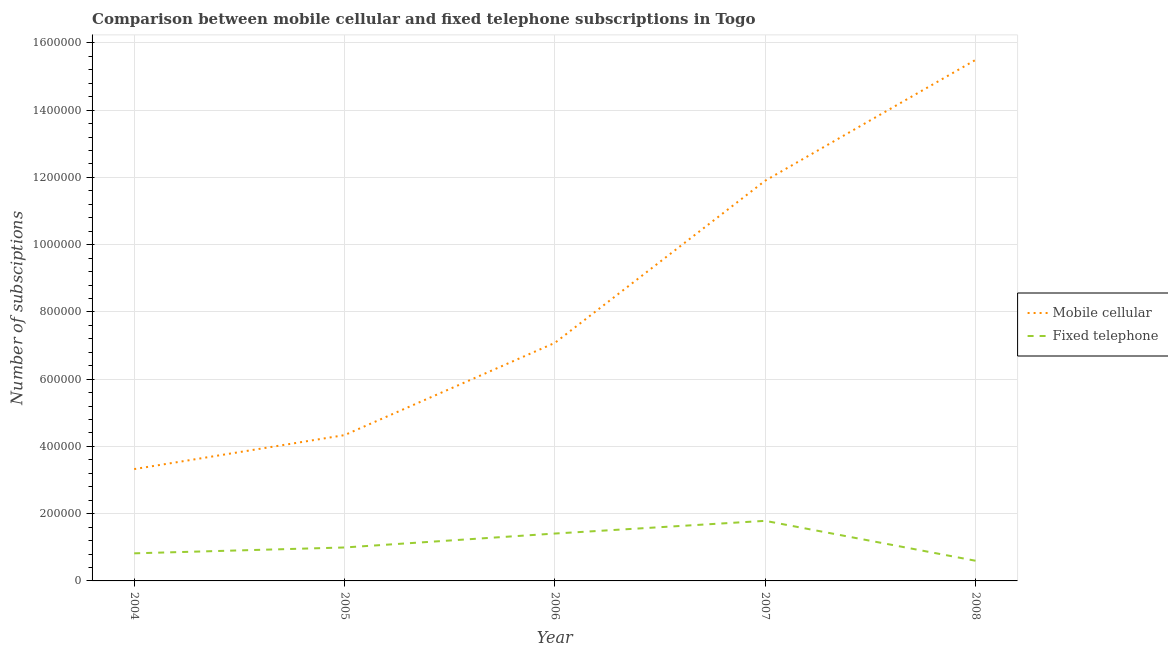Does the line corresponding to number of mobile cellular subscriptions intersect with the line corresponding to number of fixed telephone subscriptions?
Make the answer very short. No. What is the number of mobile cellular subscriptions in 2004?
Your answer should be very brief. 3.33e+05. Across all years, what is the maximum number of fixed telephone subscriptions?
Give a very brief answer. 1.79e+05. Across all years, what is the minimum number of fixed telephone subscriptions?
Provide a short and direct response. 6.00e+04. In which year was the number of mobile cellular subscriptions minimum?
Ensure brevity in your answer.  2004. What is the total number of mobile cellular subscriptions in the graph?
Make the answer very short. 4.21e+06. What is the difference between the number of fixed telephone subscriptions in 2006 and that in 2007?
Your response must be concise. -3.78e+04. What is the difference between the number of fixed telephone subscriptions in 2006 and the number of mobile cellular subscriptions in 2005?
Give a very brief answer. -2.93e+05. What is the average number of fixed telephone subscriptions per year?
Your answer should be compact. 1.12e+05. In the year 2007, what is the difference between the number of mobile cellular subscriptions and number of fixed telephone subscriptions?
Your answer should be very brief. 1.01e+06. What is the ratio of the number of mobile cellular subscriptions in 2004 to that in 2005?
Make the answer very short. 0.77. Is the number of mobile cellular subscriptions in 2006 less than that in 2007?
Give a very brief answer. Yes. What is the difference between the highest and the second highest number of mobile cellular subscriptions?
Give a very brief answer. 3.59e+05. What is the difference between the highest and the lowest number of fixed telephone subscriptions?
Your answer should be very brief. 1.19e+05. In how many years, is the number of mobile cellular subscriptions greater than the average number of mobile cellular subscriptions taken over all years?
Provide a succinct answer. 2. How many years are there in the graph?
Your response must be concise. 5. Does the graph contain any zero values?
Give a very brief answer. No. Where does the legend appear in the graph?
Provide a short and direct response. Center right. How many legend labels are there?
Offer a very short reply. 2. How are the legend labels stacked?
Ensure brevity in your answer.  Vertical. What is the title of the graph?
Provide a succinct answer. Comparison between mobile cellular and fixed telephone subscriptions in Togo. What is the label or title of the X-axis?
Offer a terse response. Year. What is the label or title of the Y-axis?
Your response must be concise. Number of subsciptions. What is the Number of subsciptions in Mobile cellular in 2004?
Offer a very short reply. 3.33e+05. What is the Number of subsciptions in Fixed telephone in 2004?
Give a very brief answer. 8.21e+04. What is the Number of subsciptions in Mobile cellular in 2005?
Provide a succinct answer. 4.34e+05. What is the Number of subsciptions of Fixed telephone in 2005?
Make the answer very short. 9.95e+04. What is the Number of subsciptions of Mobile cellular in 2006?
Provide a short and direct response. 7.08e+05. What is the Number of subsciptions of Fixed telephone in 2006?
Offer a very short reply. 1.41e+05. What is the Number of subsciptions in Mobile cellular in 2007?
Keep it short and to the point. 1.19e+06. What is the Number of subsciptions of Fixed telephone in 2007?
Keep it short and to the point. 1.79e+05. What is the Number of subsciptions in Mobile cellular in 2008?
Keep it short and to the point. 1.55e+06. What is the Number of subsciptions in Fixed telephone in 2008?
Ensure brevity in your answer.  6.00e+04. Across all years, what is the maximum Number of subsciptions in Mobile cellular?
Your response must be concise. 1.55e+06. Across all years, what is the maximum Number of subsciptions of Fixed telephone?
Your answer should be compact. 1.79e+05. Across all years, what is the minimum Number of subsciptions of Mobile cellular?
Your answer should be compact. 3.33e+05. Across all years, what is the minimum Number of subsciptions of Fixed telephone?
Keep it short and to the point. 6.00e+04. What is the total Number of subsciptions in Mobile cellular in the graph?
Ensure brevity in your answer.  4.21e+06. What is the total Number of subsciptions of Fixed telephone in the graph?
Give a very brief answer. 5.61e+05. What is the difference between the Number of subsciptions of Mobile cellular in 2004 and that in 2005?
Your answer should be compact. -1.01e+05. What is the difference between the Number of subsciptions of Fixed telephone in 2004 and that in 2005?
Provide a succinct answer. -1.74e+04. What is the difference between the Number of subsciptions in Mobile cellular in 2004 and that in 2006?
Give a very brief answer. -3.75e+05. What is the difference between the Number of subsciptions of Fixed telephone in 2004 and that in 2006?
Give a very brief answer. -5.89e+04. What is the difference between the Number of subsciptions in Mobile cellular in 2004 and that in 2007?
Provide a short and direct response. -8.58e+05. What is the difference between the Number of subsciptions in Fixed telephone in 2004 and that in 2007?
Your response must be concise. -9.67e+04. What is the difference between the Number of subsciptions in Mobile cellular in 2004 and that in 2008?
Make the answer very short. -1.22e+06. What is the difference between the Number of subsciptions in Fixed telephone in 2004 and that in 2008?
Your answer should be very brief. 2.20e+04. What is the difference between the Number of subsciptions in Mobile cellular in 2005 and that in 2006?
Your answer should be very brief. -2.74e+05. What is the difference between the Number of subsciptions of Fixed telephone in 2005 and that in 2006?
Give a very brief answer. -4.14e+04. What is the difference between the Number of subsciptions in Mobile cellular in 2005 and that in 2007?
Provide a short and direct response. -7.57e+05. What is the difference between the Number of subsciptions of Fixed telephone in 2005 and that in 2007?
Your answer should be compact. -7.92e+04. What is the difference between the Number of subsciptions of Mobile cellular in 2005 and that in 2008?
Ensure brevity in your answer.  -1.12e+06. What is the difference between the Number of subsciptions in Fixed telephone in 2005 and that in 2008?
Provide a succinct answer. 3.95e+04. What is the difference between the Number of subsciptions of Mobile cellular in 2006 and that in 2007?
Ensure brevity in your answer.  -4.82e+05. What is the difference between the Number of subsciptions in Fixed telephone in 2006 and that in 2007?
Provide a succinct answer. -3.78e+04. What is the difference between the Number of subsciptions in Mobile cellular in 2006 and that in 2008?
Ensure brevity in your answer.  -8.42e+05. What is the difference between the Number of subsciptions in Fixed telephone in 2006 and that in 2008?
Your answer should be very brief. 8.09e+04. What is the difference between the Number of subsciptions in Mobile cellular in 2007 and that in 2008?
Provide a succinct answer. -3.59e+05. What is the difference between the Number of subsciptions in Fixed telephone in 2007 and that in 2008?
Provide a succinct answer. 1.19e+05. What is the difference between the Number of subsciptions of Mobile cellular in 2004 and the Number of subsciptions of Fixed telephone in 2005?
Ensure brevity in your answer.  2.33e+05. What is the difference between the Number of subsciptions of Mobile cellular in 2004 and the Number of subsciptions of Fixed telephone in 2006?
Ensure brevity in your answer.  1.92e+05. What is the difference between the Number of subsciptions of Mobile cellular in 2004 and the Number of subsciptions of Fixed telephone in 2007?
Give a very brief answer. 1.54e+05. What is the difference between the Number of subsciptions of Mobile cellular in 2004 and the Number of subsciptions of Fixed telephone in 2008?
Offer a very short reply. 2.73e+05. What is the difference between the Number of subsciptions of Mobile cellular in 2005 and the Number of subsciptions of Fixed telephone in 2006?
Your response must be concise. 2.93e+05. What is the difference between the Number of subsciptions in Mobile cellular in 2005 and the Number of subsciptions in Fixed telephone in 2007?
Offer a terse response. 2.55e+05. What is the difference between the Number of subsciptions of Mobile cellular in 2005 and the Number of subsciptions of Fixed telephone in 2008?
Provide a short and direct response. 3.74e+05. What is the difference between the Number of subsciptions in Mobile cellular in 2006 and the Number of subsciptions in Fixed telephone in 2007?
Offer a very short reply. 5.29e+05. What is the difference between the Number of subsciptions in Mobile cellular in 2006 and the Number of subsciptions in Fixed telephone in 2008?
Your answer should be compact. 6.48e+05. What is the difference between the Number of subsciptions of Mobile cellular in 2007 and the Number of subsciptions of Fixed telephone in 2008?
Give a very brief answer. 1.13e+06. What is the average Number of subsciptions of Mobile cellular per year?
Your answer should be compact. 8.43e+05. What is the average Number of subsciptions in Fixed telephone per year?
Provide a succinct answer. 1.12e+05. In the year 2004, what is the difference between the Number of subsciptions of Mobile cellular and Number of subsciptions of Fixed telephone?
Offer a very short reply. 2.51e+05. In the year 2005, what is the difference between the Number of subsciptions in Mobile cellular and Number of subsciptions in Fixed telephone?
Provide a short and direct response. 3.34e+05. In the year 2006, what is the difference between the Number of subsciptions of Mobile cellular and Number of subsciptions of Fixed telephone?
Your answer should be very brief. 5.67e+05. In the year 2007, what is the difference between the Number of subsciptions of Mobile cellular and Number of subsciptions of Fixed telephone?
Your answer should be very brief. 1.01e+06. In the year 2008, what is the difference between the Number of subsciptions in Mobile cellular and Number of subsciptions in Fixed telephone?
Your response must be concise. 1.49e+06. What is the ratio of the Number of subsciptions of Mobile cellular in 2004 to that in 2005?
Keep it short and to the point. 0.77. What is the ratio of the Number of subsciptions in Fixed telephone in 2004 to that in 2005?
Provide a short and direct response. 0.82. What is the ratio of the Number of subsciptions of Mobile cellular in 2004 to that in 2006?
Make the answer very short. 0.47. What is the ratio of the Number of subsciptions in Fixed telephone in 2004 to that in 2006?
Keep it short and to the point. 0.58. What is the ratio of the Number of subsciptions of Mobile cellular in 2004 to that in 2007?
Your response must be concise. 0.28. What is the ratio of the Number of subsciptions in Fixed telephone in 2004 to that in 2007?
Give a very brief answer. 0.46. What is the ratio of the Number of subsciptions in Mobile cellular in 2004 to that in 2008?
Your response must be concise. 0.21. What is the ratio of the Number of subsciptions of Fixed telephone in 2004 to that in 2008?
Keep it short and to the point. 1.37. What is the ratio of the Number of subsciptions of Mobile cellular in 2005 to that in 2006?
Your answer should be compact. 0.61. What is the ratio of the Number of subsciptions of Fixed telephone in 2005 to that in 2006?
Your response must be concise. 0.71. What is the ratio of the Number of subsciptions of Mobile cellular in 2005 to that in 2007?
Your answer should be compact. 0.36. What is the ratio of the Number of subsciptions of Fixed telephone in 2005 to that in 2007?
Ensure brevity in your answer.  0.56. What is the ratio of the Number of subsciptions in Mobile cellular in 2005 to that in 2008?
Keep it short and to the point. 0.28. What is the ratio of the Number of subsciptions in Fixed telephone in 2005 to that in 2008?
Your response must be concise. 1.66. What is the ratio of the Number of subsciptions in Mobile cellular in 2006 to that in 2007?
Your answer should be very brief. 0.59. What is the ratio of the Number of subsciptions of Fixed telephone in 2006 to that in 2007?
Ensure brevity in your answer.  0.79. What is the ratio of the Number of subsciptions of Mobile cellular in 2006 to that in 2008?
Your answer should be very brief. 0.46. What is the ratio of the Number of subsciptions of Fixed telephone in 2006 to that in 2008?
Keep it short and to the point. 2.35. What is the ratio of the Number of subsciptions of Mobile cellular in 2007 to that in 2008?
Offer a very short reply. 0.77. What is the ratio of the Number of subsciptions in Fixed telephone in 2007 to that in 2008?
Ensure brevity in your answer.  2.98. What is the difference between the highest and the second highest Number of subsciptions of Mobile cellular?
Provide a short and direct response. 3.59e+05. What is the difference between the highest and the second highest Number of subsciptions in Fixed telephone?
Offer a terse response. 3.78e+04. What is the difference between the highest and the lowest Number of subsciptions in Mobile cellular?
Your response must be concise. 1.22e+06. What is the difference between the highest and the lowest Number of subsciptions of Fixed telephone?
Provide a succinct answer. 1.19e+05. 